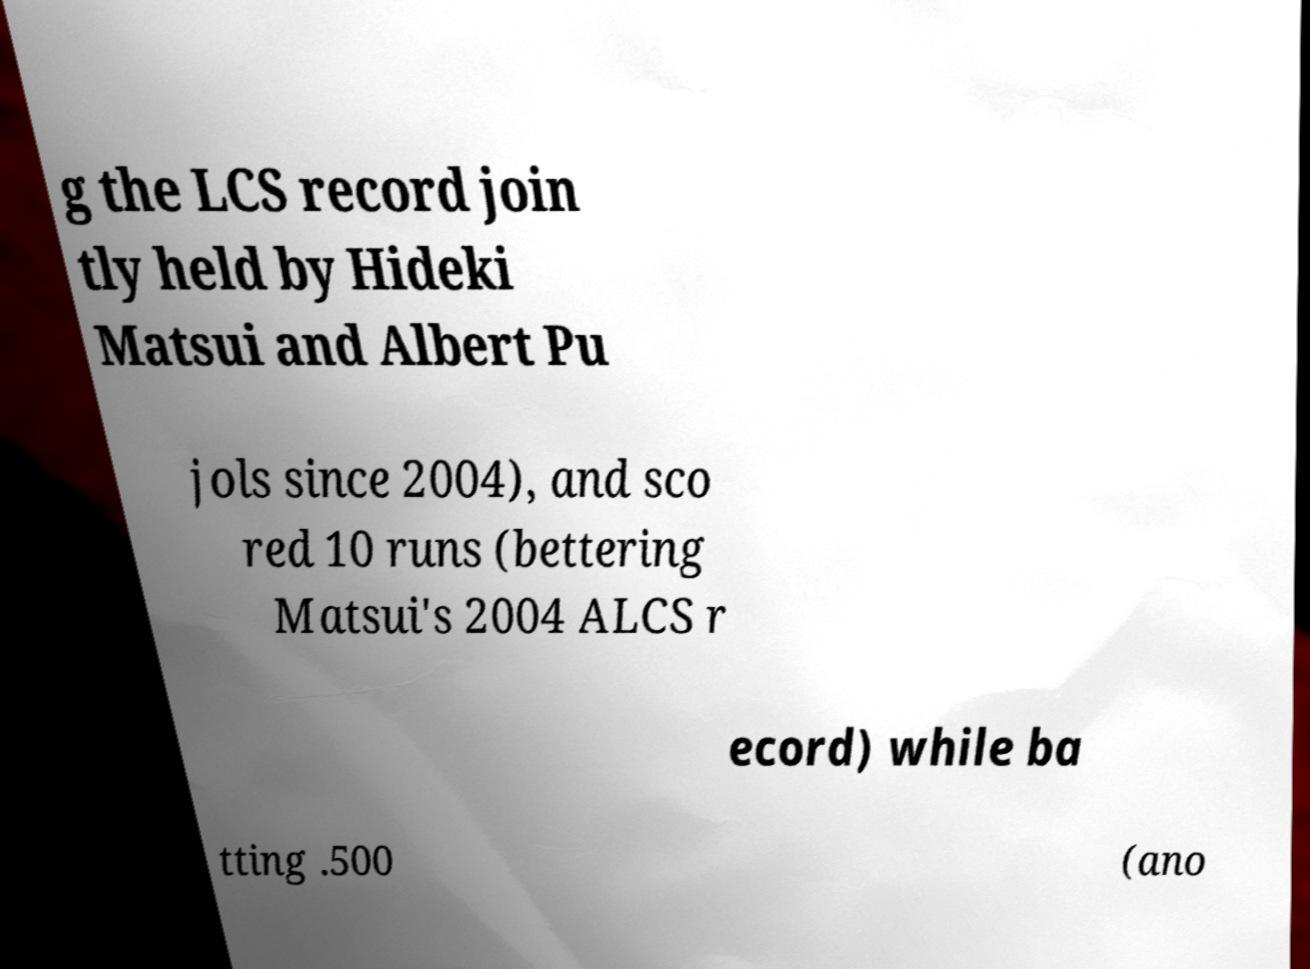Can you read and provide the text displayed in the image?This photo seems to have some interesting text. Can you extract and type it out for me? g the LCS record join tly held by Hideki Matsui and Albert Pu jols since 2004), and sco red 10 runs (bettering Matsui's 2004 ALCS r ecord) while ba tting .500 (ano 